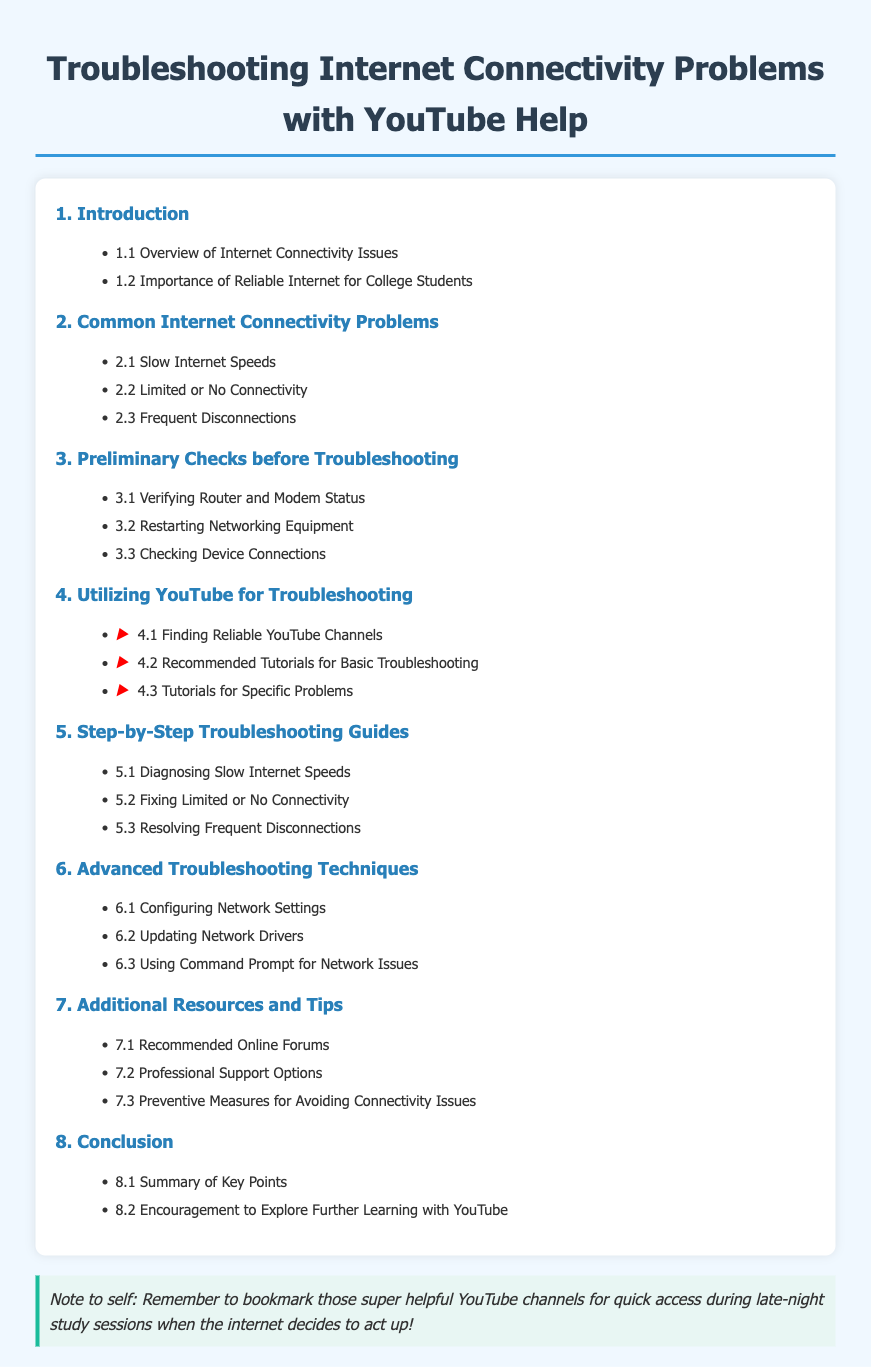what is the title of the document? The title provides the main subject of the document which is about troubleshooting connectivity problems.
Answer: Troubleshooting Internet Connectivity Problems with YouTube Help what section discusses slow internet speeds? This section covers common connectivity problems, specifically regarding slow speeds.
Answer: 2.1 Slow Internet Speeds how many main sections are in the table of contents? The total number of sections indicates the overall structure and organization of the document.
Answer: 8 what is one of the advanced troubleshooting techniques listed? This asks for a specific technique for troubleshooting that is not basic but more advanced.
Answer: Configuring Network Settings which section includes recommended online forums? This section provides additional resources to help with connectivity issues.
Answer: 7.1 Recommended Online Forums what is emphasized as important for college students? This refers to a specific point about why stable internet is critical for students' academic activities.
Answer: Importance of Reliable Internet for College Students what type of tutorials are recommended for specific problems? This points to resources tailored for resolving particular internet connectivity issues.
Answer: Tutorials for Specific Problems what does the student note suggest to do for quick access? This note includes a personal reminder about managing accessibility to useful resources during critical times.
Answer: Bookmark those super helpful YouTube channels 